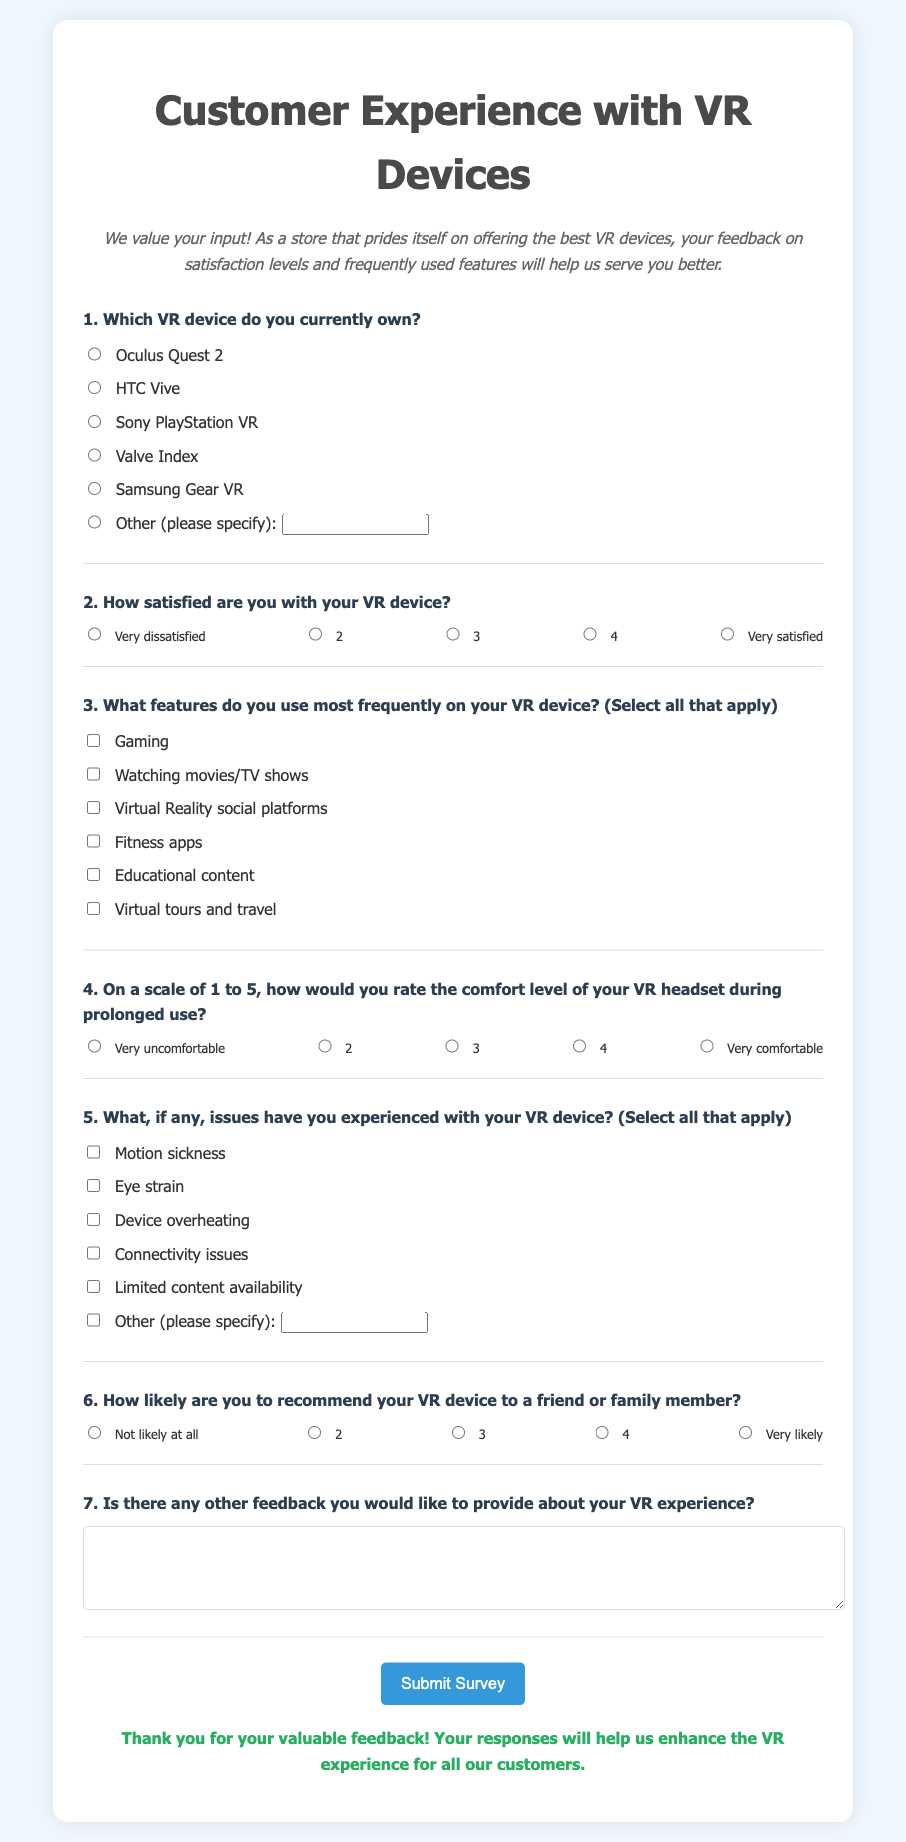What is the title of the survey? The title is displayed prominently at the top of the document, indicating the purpose of the survey.
Answer: Customer Experience with VR Devices How many options are provided for the VR device ownership question? The document lists different VR devices along with an option for others, showcasing the variety available to respondents.
Answer: 7 options What is the highest level of satisfaction on the satisfaction scale? The satisfaction question includes a range of options, with a maximum value indicating the best possible level of satisfaction.
Answer: 5 What feature is available for selection related to social interactions? Among the frequently used features listed, one specifically pertains to the interaction aspect of VR.
Answer: Virtual Reality social platforms What is the comfort rating scale's minimum value? The comfort question lists various levels, and understanding the lowest value helps gauge discomfort perception among users.
Answer: 1 How likely are respondents to recommend their VR device? The recommendation question's scale allows participants to express their likelihood of recommending the device, ranging from not likely to very likely.
Answer: 1 What is one issue mentioned in the survey that might affect user experience? The issues listed cover various potential concerns users may face, impacting their overall experience with the VR device.
Answer: Motion sickness What type of feedback is collected at the end of the survey? The survey concludes with an open-ended question, allowing for personal thoughts and experiences to be shared.
Answer: Additional feedback 